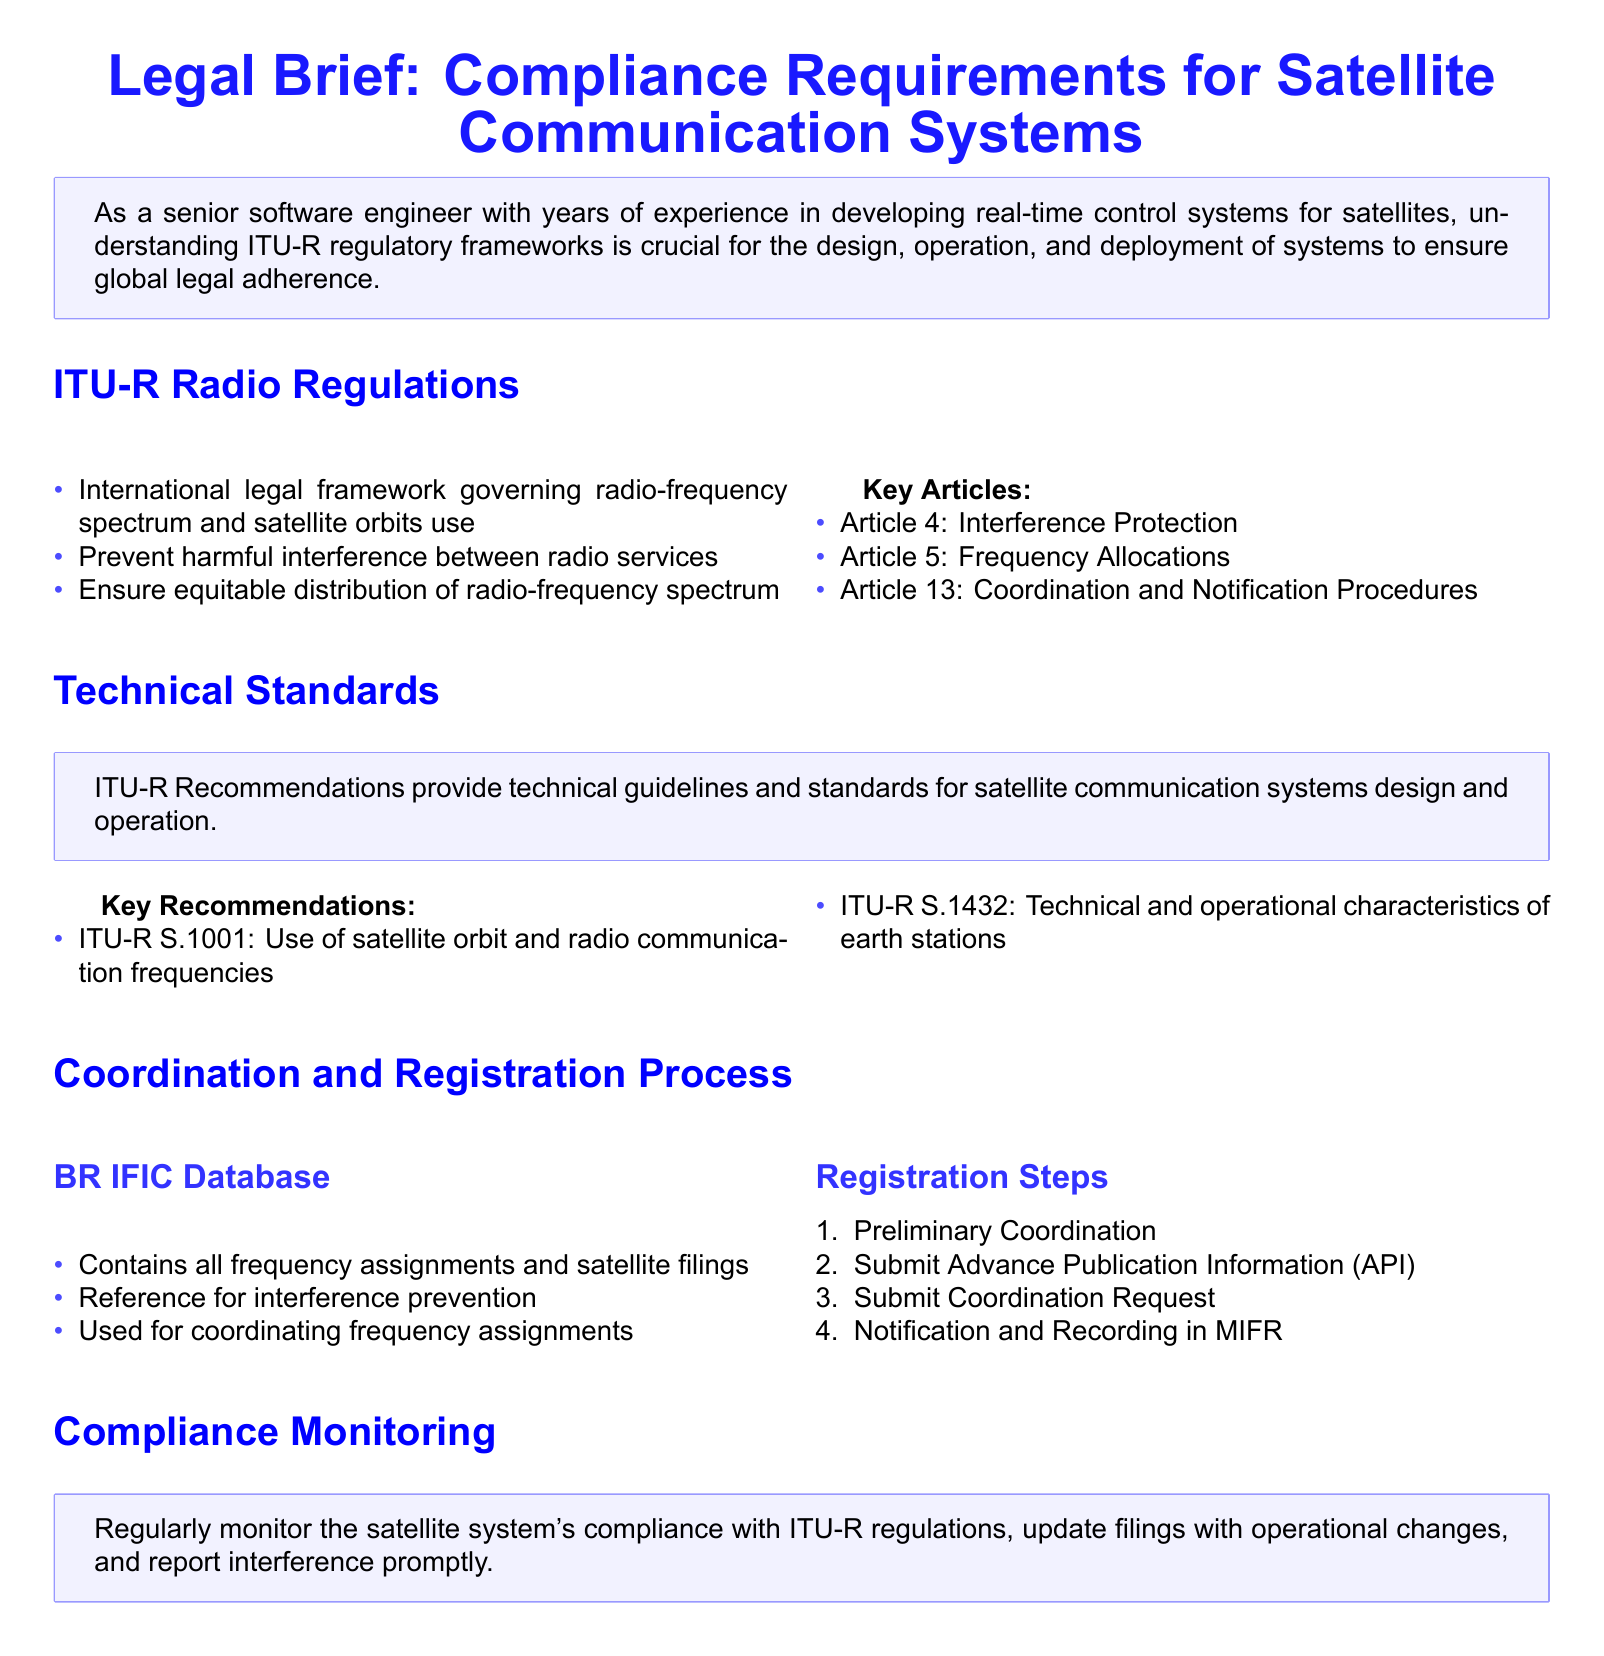What is the main focus of the document? The document outlines compliance requirements for satellite communication systems under ITU-R regulations.
Answer: Compliance requirements for satellite communication systems What is the purpose of Article 4? Article 4 relates to protection against harmful interference within satellite communications.
Answer: Interference Protection What recommendations are made for earth stations? The document lists ITU-R S.1432 as a key recommendation for technical and operational characteristics.
Answer: ITU-R S.1432 What is contained in the BR IFIC Database? The BR IFIC Database contains all frequency assignments and satellite filings for coordination and reference.
Answer: Frequency assignments and satellite filings How many steps are in the registration process? The document specifies four steps in the registration process for satellite communications.
Answer: Four Why is compliance monitoring necessary? Regular compliance monitoring is required to ensure adherence to ITU-R regulations.
Answer: To ensure adherence to ITU-R regulations What are the three key Articles mentioned in the document? The document highlights Articles 4, 5, and 13 as key regulations.
Answer: Articles 4, 5, and 13 What does ITU-R S.1001 address? ITU-R S.1001 provides guidance on the use of satellite orbit and radio communication frequencies.
Answer: Use of satellite orbit and radio communication frequencies What emphasizes the need for equitable distribution of radio-frequency spectrum? The document states that one of the key aspects of ITU-R regulations is to ensure equitable distribution.
Answer: Equitable distribution of radio-frequency spectrum 